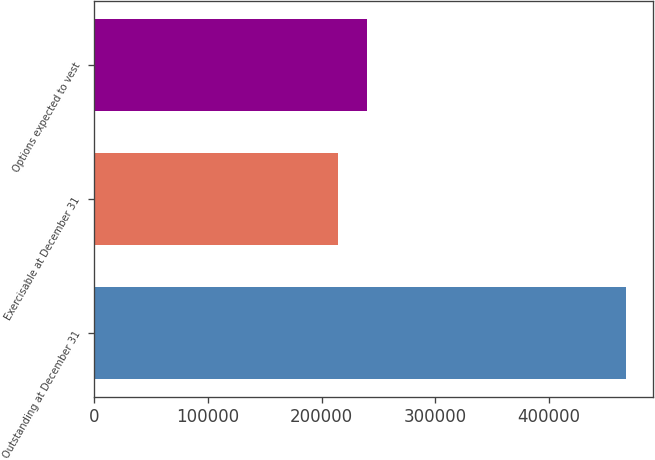Convert chart to OTSL. <chart><loc_0><loc_0><loc_500><loc_500><bar_chart><fcel>Outstanding at December 31<fcel>Exercisable at December 31<fcel>Options expected to vest<nl><fcel>467837<fcel>214377<fcel>239723<nl></chart> 